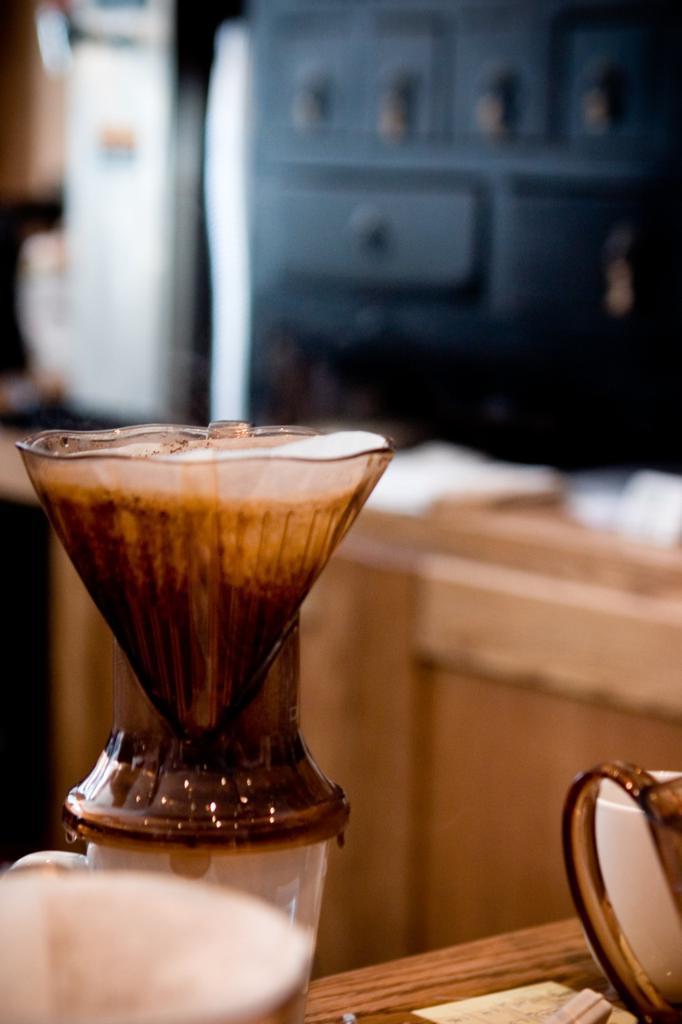In one or two sentences, can you explain what this image depicts? In this picture there is espresso on the left side of the image, which is placed on a table and the background area of the image is blurred. 